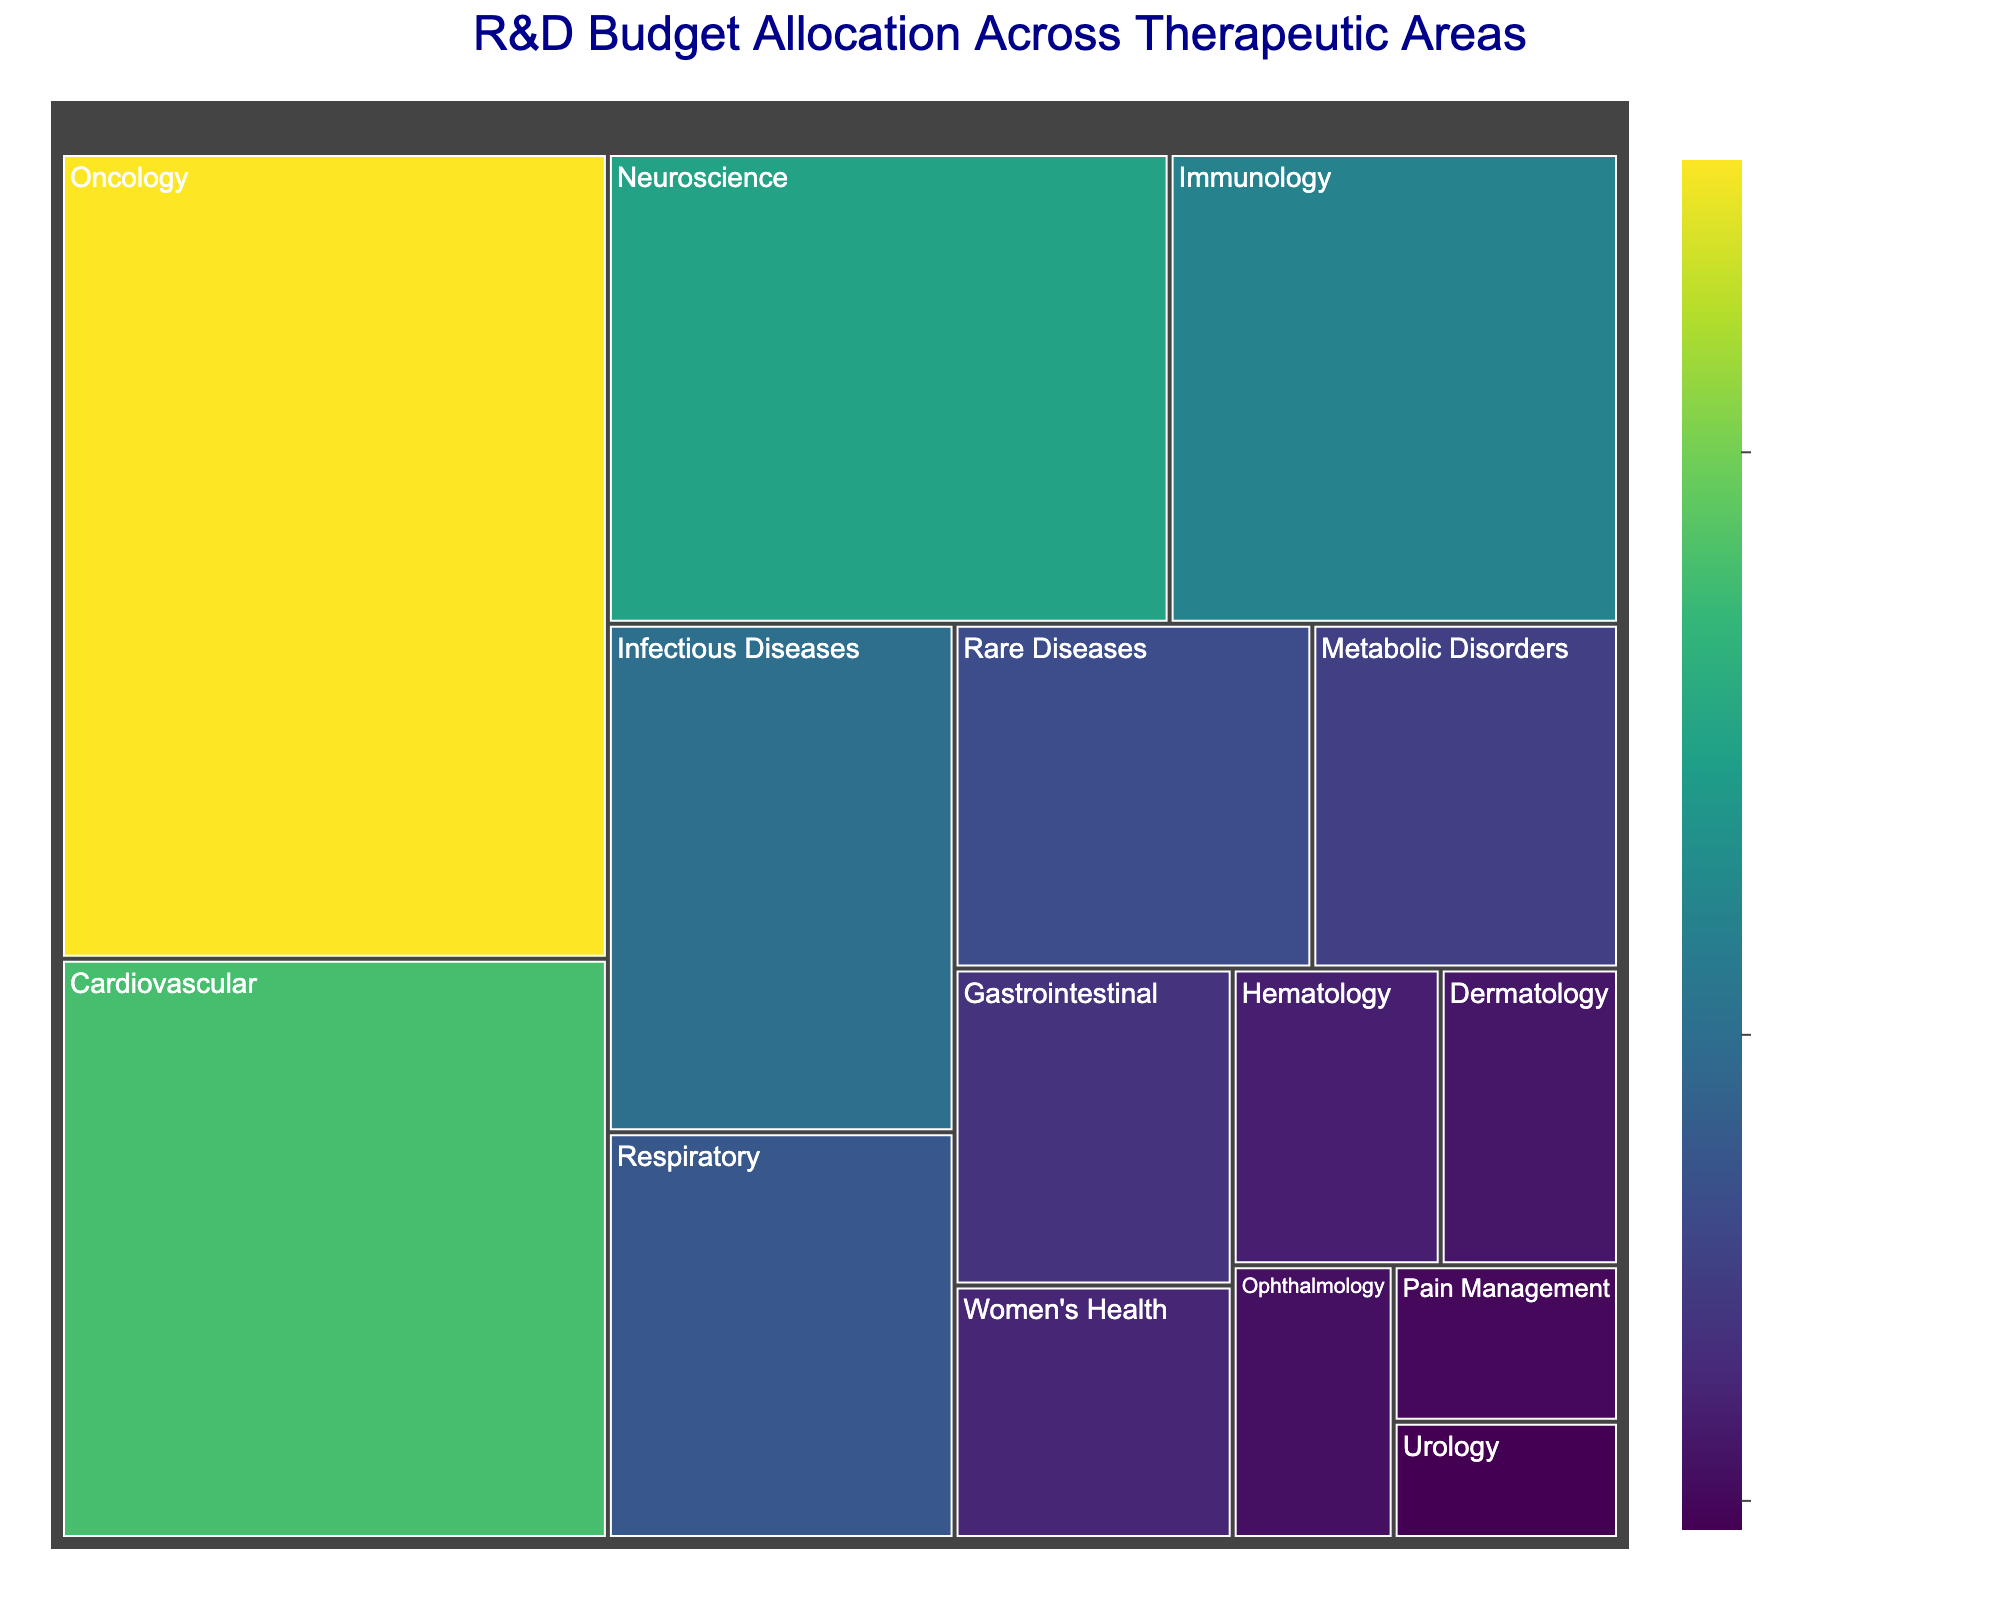What is the title of the treemap? The title is usually found at the top of the figure, clearly indicating what the chart is about. In this case, the title is "R&D Budget Allocation Across Therapeutic Areas"
Answer: R&D Budget Allocation Across Therapeutic Areas What therapeutic area has the highest budget allocation? To find the therapeutic area with the highest budget, look for the largest segment in the treemap. Oncology is the largest segment
Answer: Oncology Which therapeutic area has a budget allocation of 800 million USD? By looking at the labels in the treemap, you can find that the Respiratory therapeutic area has a budget of 800 million USD
Answer: Respiratory What is the combined budget allocation for Oncology and Cardiovascular? Add the budget for Oncology (2500 million USD) and Cardiovascular (1800 million USD). 2500 + 1800 = 4300 million USD
Answer: 4300 How does the budget for Neuroscience compare with that for Immunology? Compare the size and values of the segments for Neuroscience (1500 million USD) and Immunology (1200 million USD). Neuroscience has a higher budget than Immunology
Answer: Neuroscience has a higher budget What is the color of the segment representing the Women's Health area? Colors in the treemap are used to represent the budget size. The specific color shade from the Viridis color scale can be identified visually. For Women's Health, the color would be a shade of green/yellow as it has a smaller budget
Answer: Green/yellow shade If you combine the budgets for Rare Diseases, Metabolic Disorders, and Gastrointestinal, what is the total? Sum the budget allocations of Rare Diseases (700 million USD), Metabolic Disorders (600 million USD), and Gastrointestinal (500 million USD). 700 + 600 + 500 = 1800 million USD
Answer: 1800 Which therapeutic area has the smallest budget allocation, and what is that amount? Look for the smallest segment in the treemap. The Urology area has the smallest budget, which is 150 million USD
Answer: Urology, 150 million USD What is the average budget allocation for the following areas: Pain Management, Urology, and Dermatology? Add the budgets for Pain Management (200 million USD), Urology (150 million USD), and Dermatology (300 million USD). Then divide by 3. (200 + 150 + 300) / 3 = 650 / 3 ≈ 217 million USD
Answer: 217 How much more budget is allocated to Respiratory compared to Gastrointestinal? Subtract the budget of Gastrointestinal (500 million USD) from Respiratory (800 million USD). 800 - 500 = 300 million USD
Answer: 300 